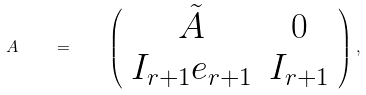Convert formula to latex. <formula><loc_0><loc_0><loc_500><loc_500>A \quad = \quad \left ( \begin{array} { c c } \tilde { A } & 0 \\ I _ { r + 1 } e _ { r + 1 } & I _ { r + 1 } \end{array} \right ) ,</formula> 